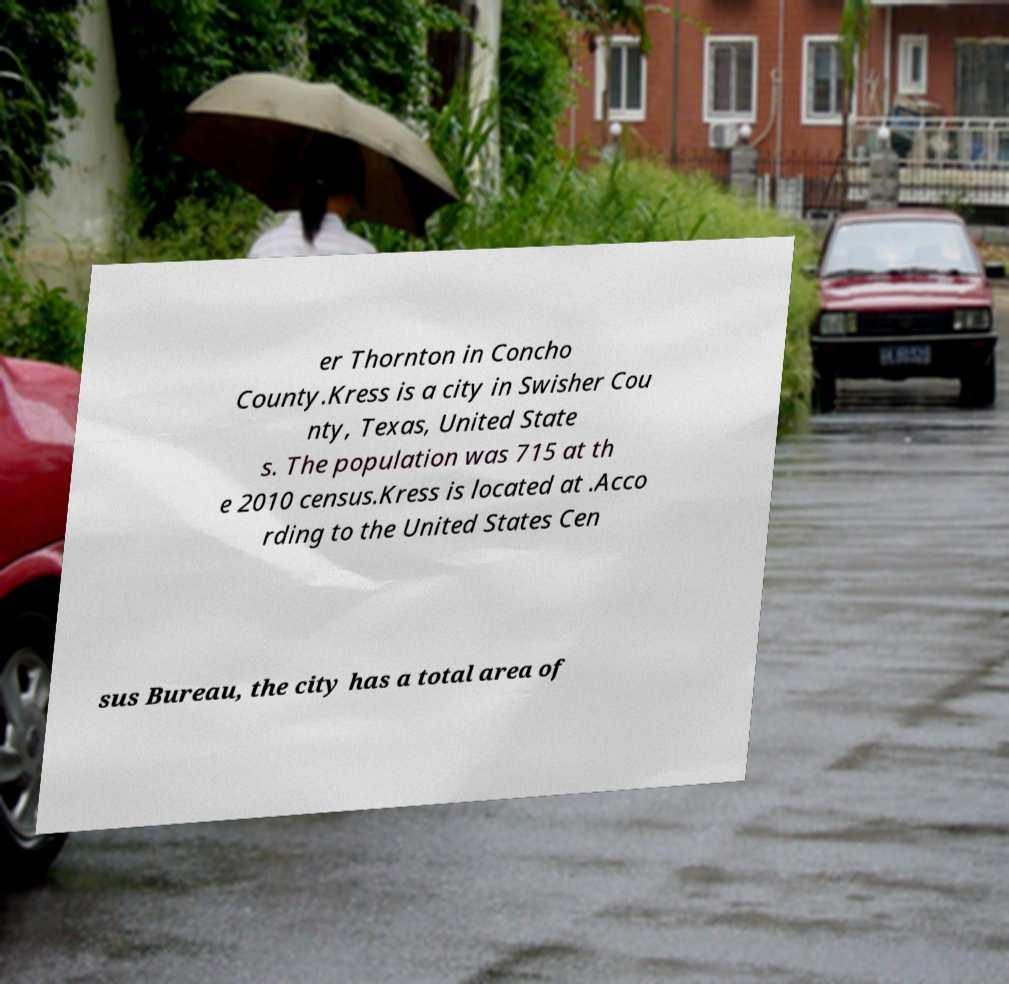I need the written content from this picture converted into text. Can you do that? er Thornton in Concho County.Kress is a city in Swisher Cou nty, Texas, United State s. The population was 715 at th e 2010 census.Kress is located at .Acco rding to the United States Cen sus Bureau, the city has a total area of 